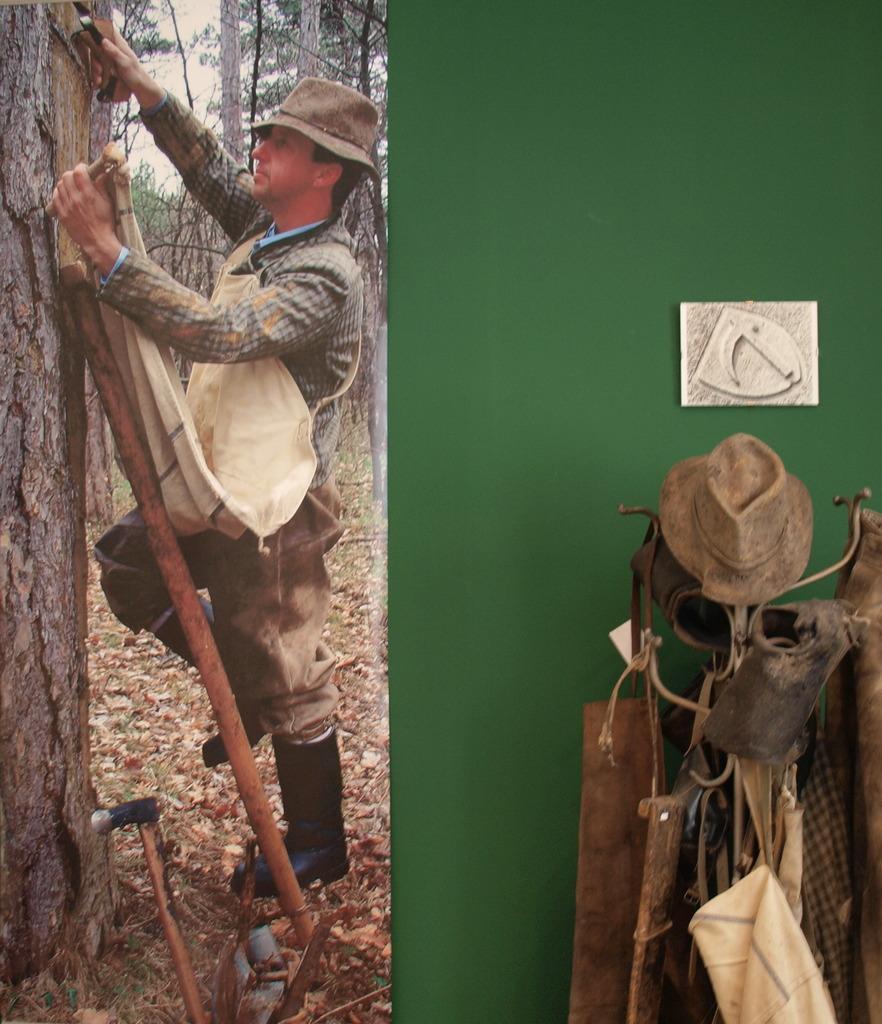How would you summarize this image in a sentence or two? On the left side of the image we can see this person wearing shirt and long boots is standing on the ladder near the tree and here we can see the dry leaves and trees in the background. On the right side of the image we can see caps and shoes and few more things are kept to the stand and we can see the green color wall in the background. 